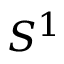Convert formula to latex. <formula><loc_0><loc_0><loc_500><loc_500>S ^ { 1 }</formula> 